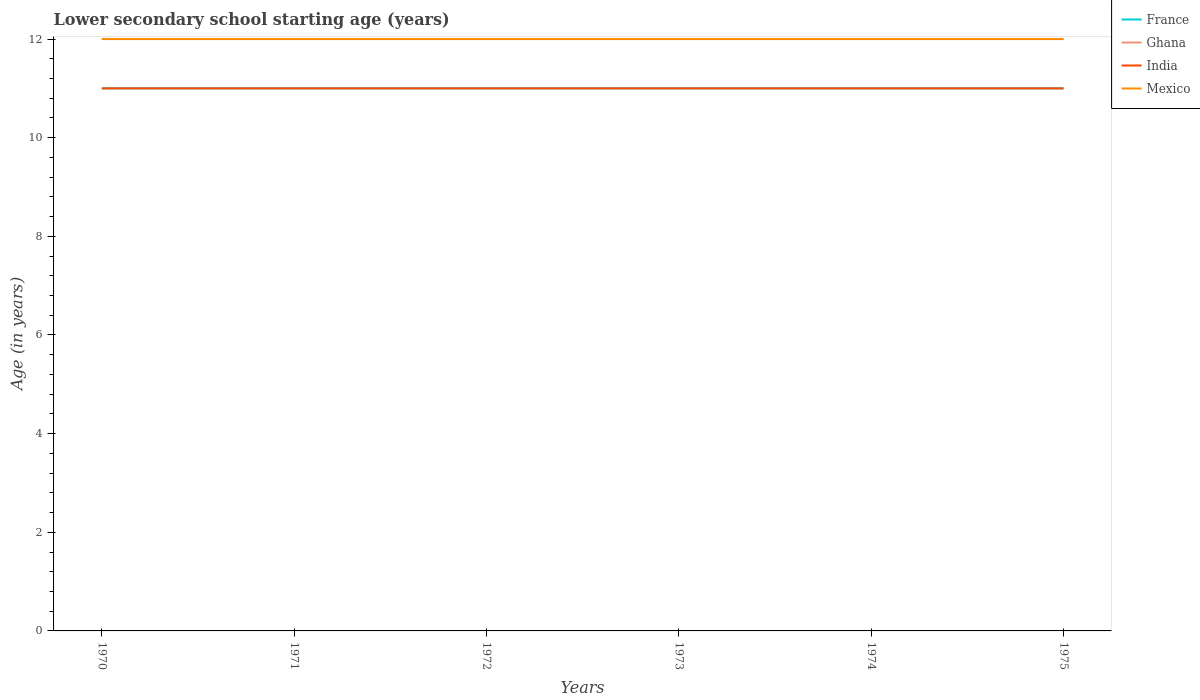How many different coloured lines are there?
Your answer should be very brief. 4. Across all years, what is the maximum lower secondary school starting age of children in Mexico?
Give a very brief answer. 12. In which year was the lower secondary school starting age of children in India maximum?
Give a very brief answer. 1970. How many lines are there?
Provide a short and direct response. 4. How many years are there in the graph?
Your answer should be compact. 6. What is the difference between two consecutive major ticks on the Y-axis?
Your response must be concise. 2. Are the values on the major ticks of Y-axis written in scientific E-notation?
Keep it short and to the point. No. Does the graph contain grids?
Your response must be concise. No. How are the legend labels stacked?
Your answer should be compact. Vertical. What is the title of the graph?
Keep it short and to the point. Lower secondary school starting age (years). What is the label or title of the Y-axis?
Ensure brevity in your answer.  Age (in years). What is the Age (in years) of Ghana in 1970?
Your answer should be very brief. 12. What is the Age (in years) in India in 1970?
Ensure brevity in your answer.  11. What is the Age (in years) of France in 1971?
Keep it short and to the point. 11. What is the Age (in years) of India in 1971?
Provide a succinct answer. 11. What is the Age (in years) of France in 1972?
Offer a terse response. 11. What is the Age (in years) of India in 1972?
Your response must be concise. 11. What is the Age (in years) in Mexico in 1972?
Offer a very short reply. 12. What is the Age (in years) in Ghana in 1973?
Your answer should be very brief. 12. What is the Age (in years) of India in 1973?
Your answer should be compact. 11. What is the Age (in years) in Mexico in 1973?
Make the answer very short. 12. What is the Age (in years) in France in 1974?
Your answer should be compact. 11. What is the Age (in years) of Ghana in 1974?
Offer a terse response. 12. What is the Age (in years) in France in 1975?
Provide a short and direct response. 11. What is the Age (in years) of Mexico in 1975?
Ensure brevity in your answer.  12. Across all years, what is the maximum Age (in years) in France?
Provide a short and direct response. 11. What is the total Age (in years) in India in the graph?
Give a very brief answer. 66. What is the total Age (in years) of Mexico in the graph?
Keep it short and to the point. 72. What is the difference between the Age (in years) in France in 1970 and that in 1972?
Make the answer very short. 0. What is the difference between the Age (in years) in Ghana in 1970 and that in 1973?
Your response must be concise. 0. What is the difference between the Age (in years) of India in 1970 and that in 1974?
Your answer should be very brief. 0. What is the difference between the Age (in years) in Ghana in 1970 and that in 1975?
Offer a very short reply. 0. What is the difference between the Age (in years) in Mexico in 1970 and that in 1975?
Make the answer very short. 0. What is the difference between the Age (in years) in France in 1971 and that in 1972?
Make the answer very short. 0. What is the difference between the Age (in years) of India in 1971 and that in 1972?
Provide a short and direct response. 0. What is the difference between the Age (in years) in Mexico in 1971 and that in 1972?
Keep it short and to the point. 0. What is the difference between the Age (in years) of Ghana in 1971 and that in 1973?
Your answer should be compact. 0. What is the difference between the Age (in years) of Ghana in 1971 and that in 1974?
Give a very brief answer. 0. What is the difference between the Age (in years) of Mexico in 1971 and that in 1974?
Give a very brief answer. 0. What is the difference between the Age (in years) of France in 1971 and that in 1975?
Offer a very short reply. 0. What is the difference between the Age (in years) in Ghana in 1971 and that in 1975?
Keep it short and to the point. 0. What is the difference between the Age (in years) in India in 1971 and that in 1975?
Offer a terse response. 0. What is the difference between the Age (in years) in Mexico in 1971 and that in 1975?
Your answer should be very brief. 0. What is the difference between the Age (in years) of Ghana in 1972 and that in 1973?
Provide a succinct answer. 0. What is the difference between the Age (in years) of India in 1972 and that in 1974?
Keep it short and to the point. 0. What is the difference between the Age (in years) of Mexico in 1972 and that in 1974?
Give a very brief answer. 0. What is the difference between the Age (in years) of France in 1972 and that in 1975?
Provide a succinct answer. 0. What is the difference between the Age (in years) of India in 1972 and that in 1975?
Your answer should be compact. 0. What is the difference between the Age (in years) in France in 1973 and that in 1974?
Keep it short and to the point. 0. What is the difference between the Age (in years) of Ghana in 1973 and that in 1974?
Make the answer very short. 0. What is the difference between the Age (in years) of India in 1973 and that in 1974?
Your answer should be compact. 0. What is the difference between the Age (in years) of India in 1973 and that in 1975?
Provide a succinct answer. 0. What is the difference between the Age (in years) in Ghana in 1974 and that in 1975?
Your answer should be very brief. 0. What is the difference between the Age (in years) of Ghana in 1970 and the Age (in years) of India in 1971?
Make the answer very short. 1. What is the difference between the Age (in years) in India in 1970 and the Age (in years) in Mexico in 1971?
Provide a succinct answer. -1. What is the difference between the Age (in years) of France in 1970 and the Age (in years) of Ghana in 1972?
Your answer should be very brief. -1. What is the difference between the Age (in years) in France in 1970 and the Age (in years) in India in 1972?
Provide a succinct answer. 0. What is the difference between the Age (in years) in France in 1970 and the Age (in years) in Mexico in 1972?
Provide a short and direct response. -1. What is the difference between the Age (in years) in Ghana in 1970 and the Age (in years) in India in 1972?
Your answer should be very brief. 1. What is the difference between the Age (in years) in France in 1970 and the Age (in years) in Ghana in 1973?
Your answer should be very brief. -1. What is the difference between the Age (in years) of Ghana in 1970 and the Age (in years) of India in 1973?
Offer a terse response. 1. What is the difference between the Age (in years) in India in 1970 and the Age (in years) in Mexico in 1973?
Your answer should be very brief. -1. What is the difference between the Age (in years) in France in 1970 and the Age (in years) in Ghana in 1974?
Keep it short and to the point. -1. What is the difference between the Age (in years) in France in 1970 and the Age (in years) in India in 1974?
Ensure brevity in your answer.  0. What is the difference between the Age (in years) of Ghana in 1970 and the Age (in years) of India in 1974?
Your answer should be very brief. 1. What is the difference between the Age (in years) of Ghana in 1970 and the Age (in years) of Mexico in 1974?
Your answer should be very brief. 0. What is the difference between the Age (in years) in India in 1970 and the Age (in years) in Mexico in 1974?
Offer a very short reply. -1. What is the difference between the Age (in years) of France in 1970 and the Age (in years) of Ghana in 1975?
Keep it short and to the point. -1. What is the difference between the Age (in years) of France in 1970 and the Age (in years) of India in 1975?
Give a very brief answer. 0. What is the difference between the Age (in years) of France in 1970 and the Age (in years) of Mexico in 1975?
Keep it short and to the point. -1. What is the difference between the Age (in years) of Ghana in 1970 and the Age (in years) of Mexico in 1975?
Provide a succinct answer. 0. What is the difference between the Age (in years) in India in 1970 and the Age (in years) in Mexico in 1975?
Give a very brief answer. -1. What is the difference between the Age (in years) of Ghana in 1971 and the Age (in years) of India in 1972?
Keep it short and to the point. 1. What is the difference between the Age (in years) of Ghana in 1971 and the Age (in years) of Mexico in 1972?
Provide a short and direct response. 0. What is the difference between the Age (in years) in India in 1971 and the Age (in years) in Mexico in 1972?
Make the answer very short. -1. What is the difference between the Age (in years) of France in 1971 and the Age (in years) of Ghana in 1973?
Offer a terse response. -1. What is the difference between the Age (in years) of Ghana in 1971 and the Age (in years) of India in 1973?
Your answer should be compact. 1. What is the difference between the Age (in years) in India in 1971 and the Age (in years) in Mexico in 1973?
Your response must be concise. -1. What is the difference between the Age (in years) of France in 1971 and the Age (in years) of Ghana in 1974?
Your response must be concise. -1. What is the difference between the Age (in years) in Ghana in 1971 and the Age (in years) in Mexico in 1974?
Your response must be concise. 0. What is the difference between the Age (in years) in India in 1971 and the Age (in years) in Mexico in 1974?
Offer a very short reply. -1. What is the difference between the Age (in years) of France in 1971 and the Age (in years) of India in 1975?
Ensure brevity in your answer.  0. What is the difference between the Age (in years) in Ghana in 1971 and the Age (in years) in Mexico in 1975?
Your answer should be compact. 0. What is the difference between the Age (in years) in India in 1971 and the Age (in years) in Mexico in 1975?
Provide a short and direct response. -1. What is the difference between the Age (in years) in France in 1972 and the Age (in years) in India in 1973?
Provide a succinct answer. 0. What is the difference between the Age (in years) in Ghana in 1972 and the Age (in years) in India in 1973?
Offer a very short reply. 1. What is the difference between the Age (in years) in Ghana in 1972 and the Age (in years) in Mexico in 1973?
Ensure brevity in your answer.  0. What is the difference between the Age (in years) in Ghana in 1972 and the Age (in years) in India in 1974?
Make the answer very short. 1. What is the difference between the Age (in years) of Ghana in 1972 and the Age (in years) of Mexico in 1974?
Provide a short and direct response. 0. What is the difference between the Age (in years) in France in 1972 and the Age (in years) in Mexico in 1975?
Make the answer very short. -1. What is the difference between the Age (in years) of France in 1973 and the Age (in years) of Ghana in 1974?
Offer a terse response. -1. What is the difference between the Age (in years) of France in 1973 and the Age (in years) of India in 1974?
Your response must be concise. 0. What is the difference between the Age (in years) in Ghana in 1973 and the Age (in years) in India in 1974?
Give a very brief answer. 1. What is the difference between the Age (in years) in India in 1973 and the Age (in years) in Mexico in 1974?
Make the answer very short. -1. What is the difference between the Age (in years) in France in 1974 and the Age (in years) in Mexico in 1975?
Your answer should be compact. -1. What is the difference between the Age (in years) in Ghana in 1974 and the Age (in years) in India in 1975?
Give a very brief answer. 1. What is the difference between the Age (in years) of India in 1974 and the Age (in years) of Mexico in 1975?
Ensure brevity in your answer.  -1. What is the average Age (in years) of India per year?
Your answer should be very brief. 11. What is the average Age (in years) of Mexico per year?
Give a very brief answer. 12. In the year 1970, what is the difference between the Age (in years) in France and Age (in years) in Ghana?
Offer a very short reply. -1. In the year 1970, what is the difference between the Age (in years) of France and Age (in years) of Mexico?
Offer a terse response. -1. In the year 1970, what is the difference between the Age (in years) in Ghana and Age (in years) in Mexico?
Offer a terse response. 0. In the year 1971, what is the difference between the Age (in years) in France and Age (in years) in India?
Keep it short and to the point. 0. In the year 1971, what is the difference between the Age (in years) of France and Age (in years) of Mexico?
Give a very brief answer. -1. In the year 1971, what is the difference between the Age (in years) in Ghana and Age (in years) in India?
Your response must be concise. 1. In the year 1971, what is the difference between the Age (in years) in Ghana and Age (in years) in Mexico?
Give a very brief answer. 0. In the year 1972, what is the difference between the Age (in years) of France and Age (in years) of India?
Your answer should be compact. 0. In the year 1972, what is the difference between the Age (in years) of France and Age (in years) of Mexico?
Keep it short and to the point. -1. In the year 1972, what is the difference between the Age (in years) in Ghana and Age (in years) in India?
Your response must be concise. 1. In the year 1972, what is the difference between the Age (in years) in Ghana and Age (in years) in Mexico?
Offer a terse response. 0. In the year 1972, what is the difference between the Age (in years) in India and Age (in years) in Mexico?
Make the answer very short. -1. In the year 1973, what is the difference between the Age (in years) in France and Age (in years) in India?
Ensure brevity in your answer.  0. In the year 1973, what is the difference between the Age (in years) of Ghana and Age (in years) of India?
Offer a terse response. 1. In the year 1973, what is the difference between the Age (in years) in Ghana and Age (in years) in Mexico?
Offer a terse response. 0. In the year 1974, what is the difference between the Age (in years) in France and Age (in years) in Ghana?
Provide a short and direct response. -1. In the year 1974, what is the difference between the Age (in years) in France and Age (in years) in India?
Ensure brevity in your answer.  0. In the year 1974, what is the difference between the Age (in years) in France and Age (in years) in Mexico?
Provide a short and direct response. -1. In the year 1974, what is the difference between the Age (in years) of India and Age (in years) of Mexico?
Ensure brevity in your answer.  -1. In the year 1975, what is the difference between the Age (in years) in France and Age (in years) in Mexico?
Your answer should be compact. -1. In the year 1975, what is the difference between the Age (in years) in Ghana and Age (in years) in India?
Your response must be concise. 1. In the year 1975, what is the difference between the Age (in years) in Ghana and Age (in years) in Mexico?
Your response must be concise. 0. What is the ratio of the Age (in years) in India in 1970 to that in 1971?
Keep it short and to the point. 1. What is the ratio of the Age (in years) of Mexico in 1970 to that in 1971?
Provide a short and direct response. 1. What is the ratio of the Age (in years) in India in 1970 to that in 1972?
Keep it short and to the point. 1. What is the ratio of the Age (in years) in France in 1970 to that in 1973?
Your answer should be very brief. 1. What is the ratio of the Age (in years) of India in 1970 to that in 1973?
Provide a short and direct response. 1. What is the ratio of the Age (in years) of Mexico in 1970 to that in 1973?
Keep it short and to the point. 1. What is the ratio of the Age (in years) of Ghana in 1970 to that in 1974?
Offer a very short reply. 1. What is the ratio of the Age (in years) of Mexico in 1970 to that in 1974?
Your answer should be very brief. 1. What is the ratio of the Age (in years) of India in 1970 to that in 1975?
Provide a succinct answer. 1. What is the ratio of the Age (in years) of Mexico in 1970 to that in 1975?
Your response must be concise. 1. What is the ratio of the Age (in years) in Ghana in 1971 to that in 1972?
Make the answer very short. 1. What is the ratio of the Age (in years) of Mexico in 1971 to that in 1972?
Offer a very short reply. 1. What is the ratio of the Age (in years) of India in 1971 to that in 1973?
Your response must be concise. 1. What is the ratio of the Age (in years) in Mexico in 1971 to that in 1973?
Offer a very short reply. 1. What is the ratio of the Age (in years) of France in 1971 to that in 1974?
Give a very brief answer. 1. What is the ratio of the Age (in years) in France in 1971 to that in 1975?
Give a very brief answer. 1. What is the ratio of the Age (in years) in Mexico in 1971 to that in 1975?
Ensure brevity in your answer.  1. What is the ratio of the Age (in years) of Mexico in 1972 to that in 1973?
Provide a short and direct response. 1. What is the ratio of the Age (in years) in Ghana in 1972 to that in 1974?
Ensure brevity in your answer.  1. What is the ratio of the Age (in years) in India in 1972 to that in 1974?
Offer a terse response. 1. What is the ratio of the Age (in years) in Mexico in 1972 to that in 1974?
Your response must be concise. 1. What is the ratio of the Age (in years) in India in 1973 to that in 1974?
Give a very brief answer. 1. What is the ratio of the Age (in years) in France in 1973 to that in 1975?
Provide a short and direct response. 1. What is the ratio of the Age (in years) of Ghana in 1973 to that in 1975?
Your answer should be compact. 1. What is the ratio of the Age (in years) in India in 1973 to that in 1975?
Provide a succinct answer. 1. What is the ratio of the Age (in years) of Mexico in 1973 to that in 1975?
Provide a succinct answer. 1. What is the ratio of the Age (in years) of India in 1974 to that in 1975?
Your answer should be compact. 1. What is the difference between the highest and the second highest Age (in years) in Mexico?
Your answer should be compact. 0. What is the difference between the highest and the lowest Age (in years) in France?
Offer a terse response. 0. What is the difference between the highest and the lowest Age (in years) of Ghana?
Give a very brief answer. 0. What is the difference between the highest and the lowest Age (in years) in India?
Your answer should be compact. 0. What is the difference between the highest and the lowest Age (in years) of Mexico?
Offer a terse response. 0. 